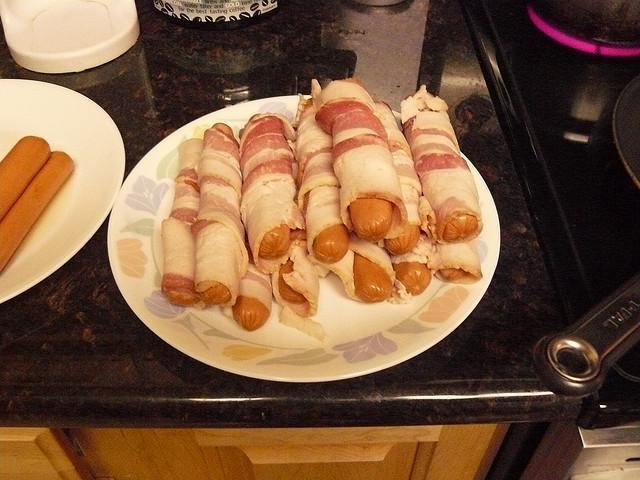How many hot dogs are pictured that are wrapped in bacon?
Give a very brief answer. 12. How many plates have food?
Give a very brief answer. 2. How many hot dogs are there?
Give a very brief answer. 10. How many buses are on the street?
Give a very brief answer. 0. 